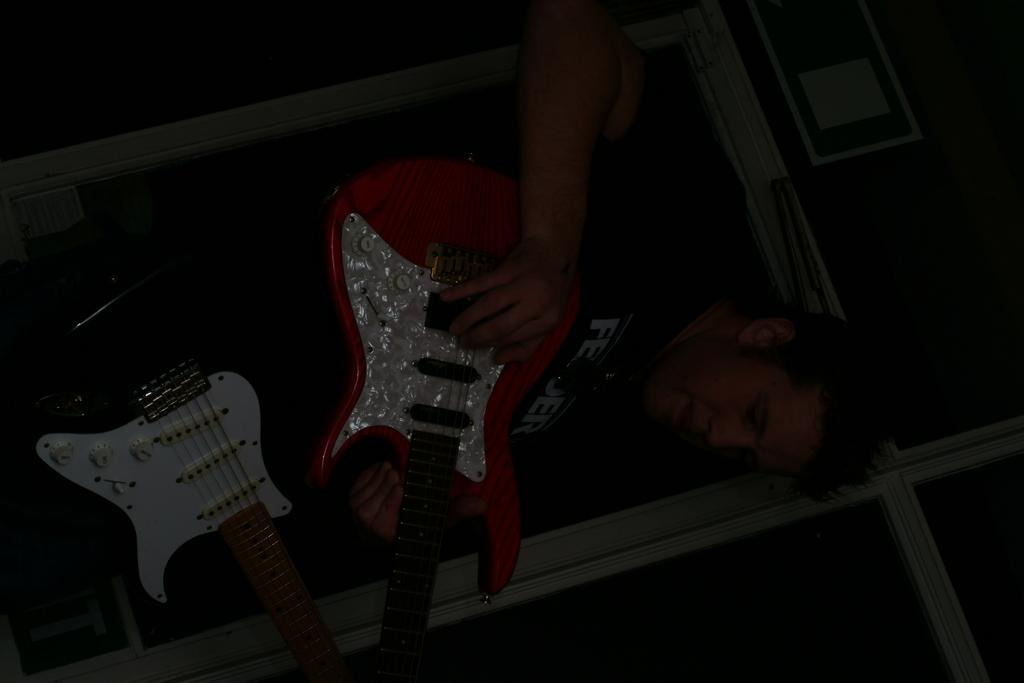What musical instruments are present in the image? There are two guitars in the image. What is the person in the image doing with the guitars? The person is handling the guitars. What can be seen in the background of the image? There is a wall in the background of the image. How many brothers are playing the guitars in the image? There is no mention of brothers or anyone playing the guitars in the image. The person is simply handling the guitars. 